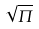<formula> <loc_0><loc_0><loc_500><loc_500>\sqrt { \Pi }</formula> 